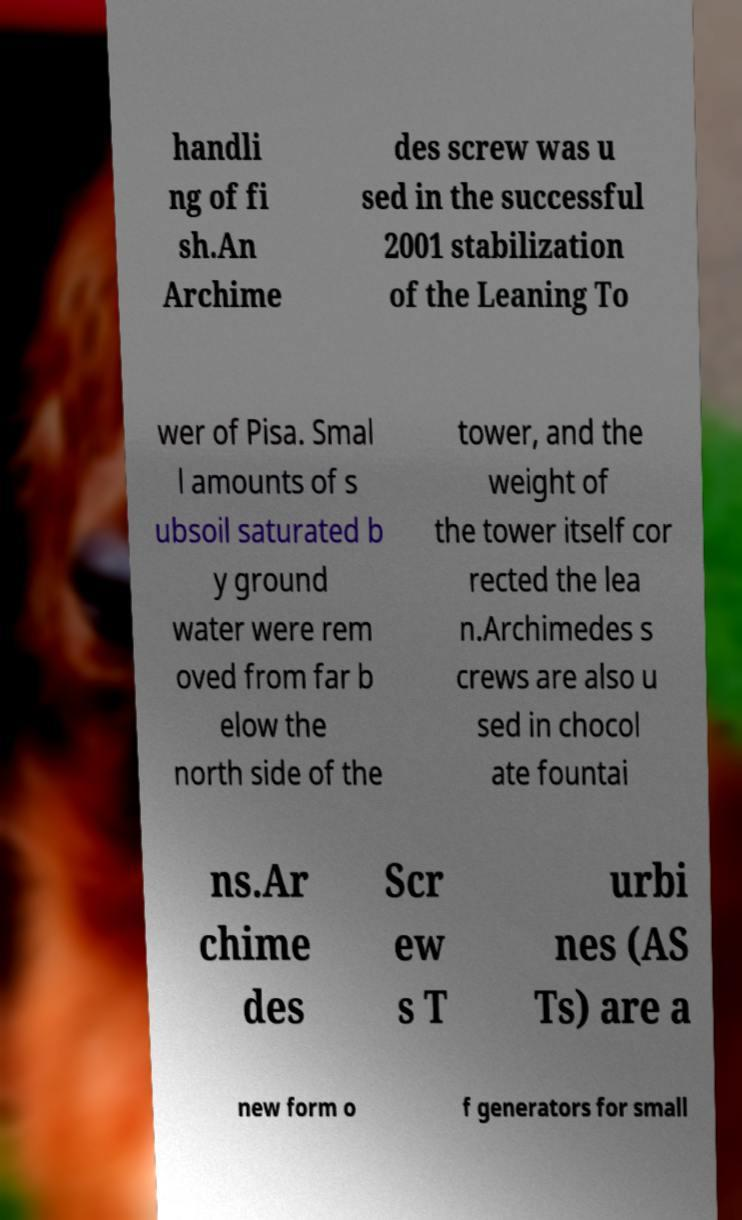Can you accurately transcribe the text from the provided image for me? handli ng of fi sh.An Archime des screw was u sed in the successful 2001 stabilization of the Leaning To wer of Pisa. Smal l amounts of s ubsoil saturated b y ground water were rem oved from far b elow the north side of the tower, and the weight of the tower itself cor rected the lea n.Archimedes s crews are also u sed in chocol ate fountai ns.Ar chime des Scr ew s T urbi nes (AS Ts) are a new form o f generators for small 